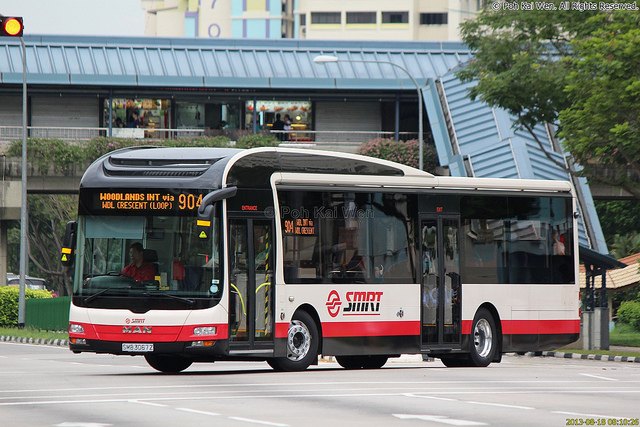<image>Where is this bus going? It is unknown where the bus is going. It can be 'woodlands', 'mtn crescent loop', or 'crescent.' Where is this bus going? I can't determine where this bus is going. 